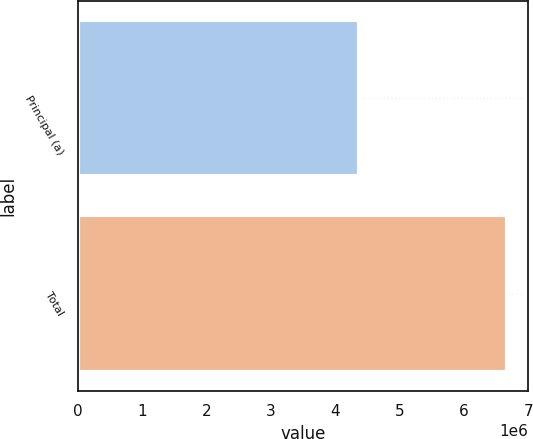Convert chart. <chart><loc_0><loc_0><loc_500><loc_500><bar_chart><fcel>Principal (a)<fcel>Total<nl><fcel>4.36652e+06<fcel>6.66882e+06<nl></chart> 